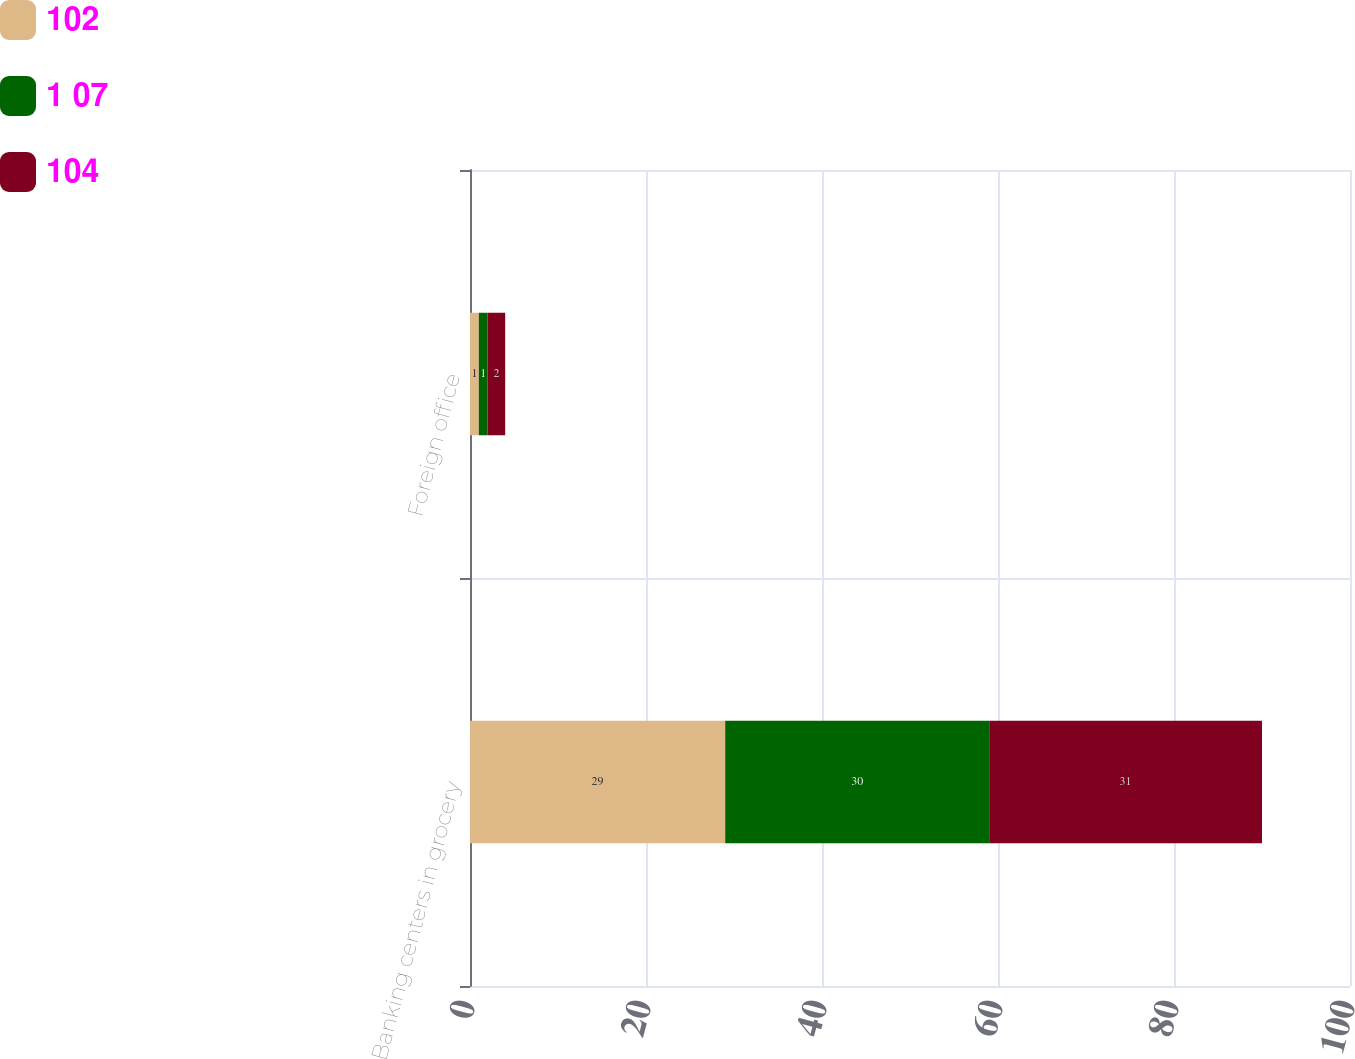Convert chart. <chart><loc_0><loc_0><loc_500><loc_500><stacked_bar_chart><ecel><fcel>Banking centers in grocery<fcel>Foreign office<nl><fcel>102<fcel>29<fcel>1<nl><fcel>1 07<fcel>30<fcel>1<nl><fcel>104<fcel>31<fcel>2<nl></chart> 